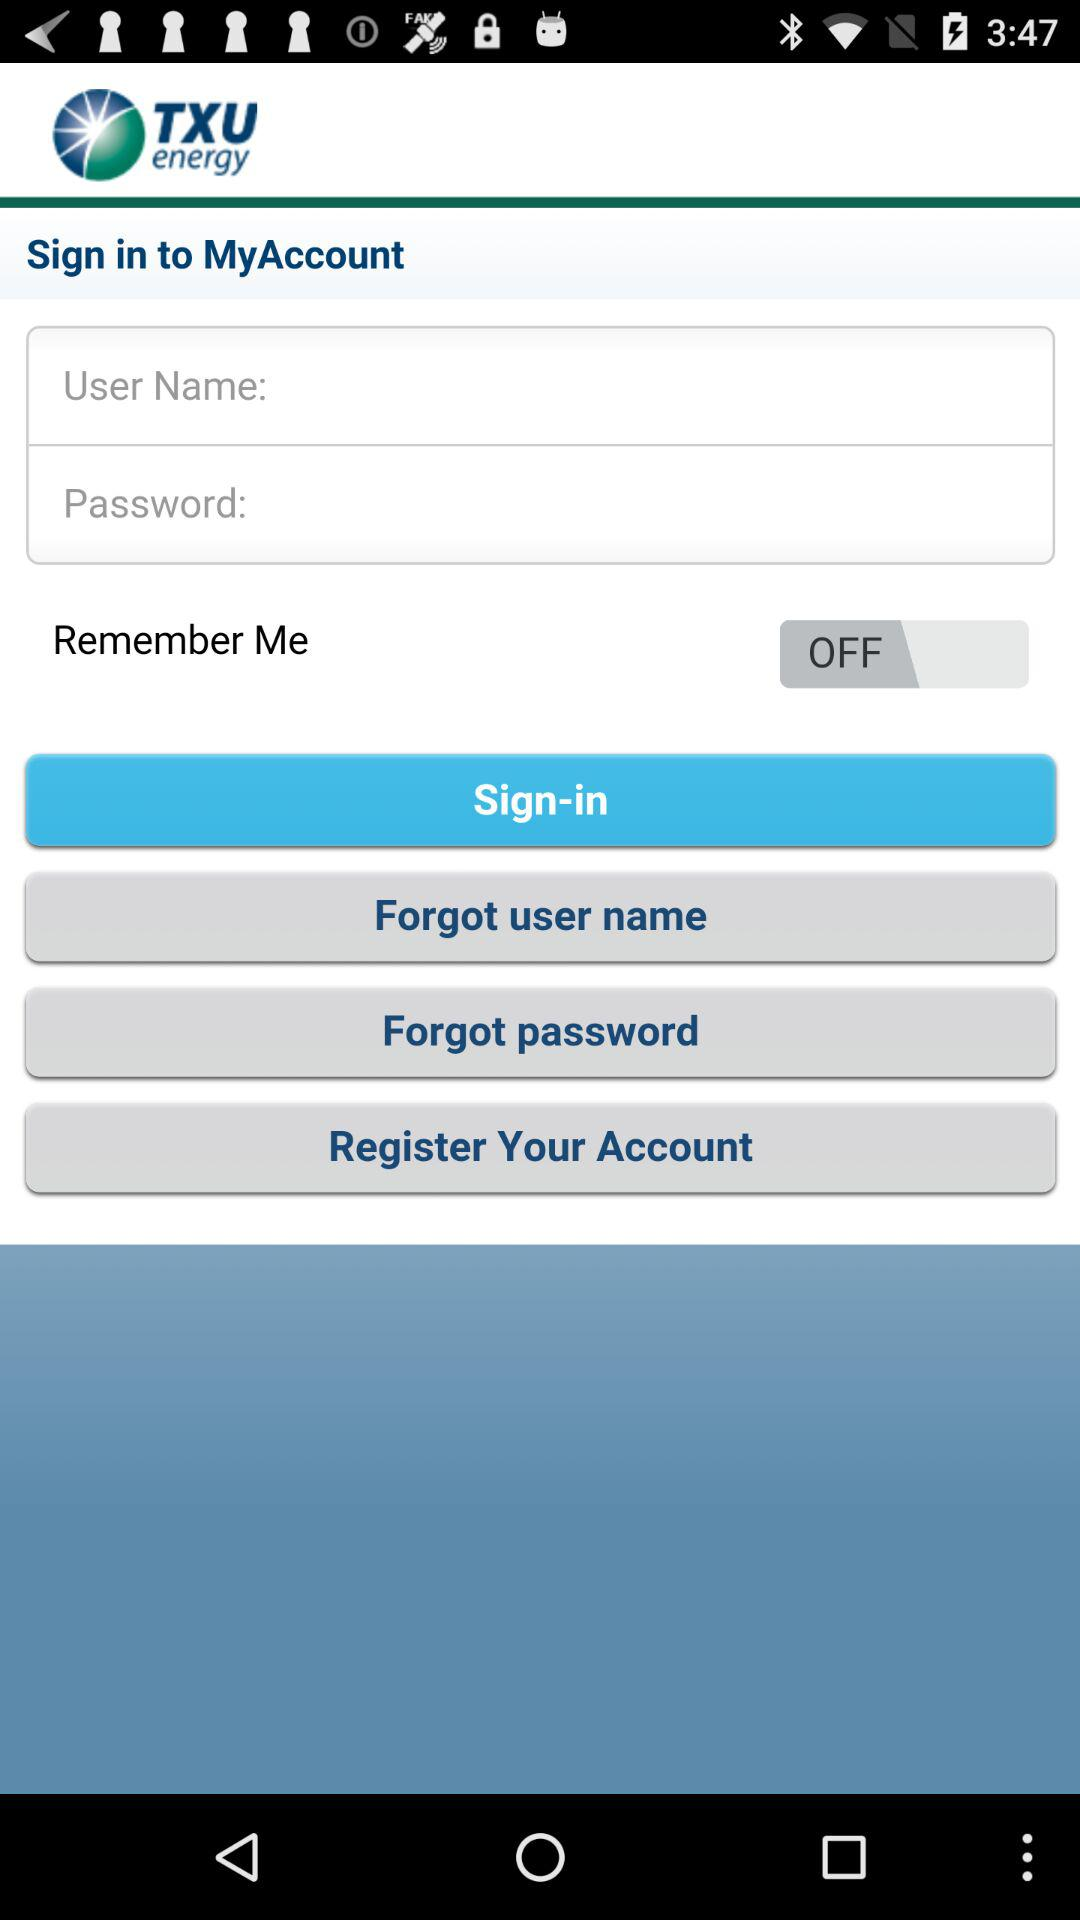What is the status of "Remember Me"? The status is "off". 